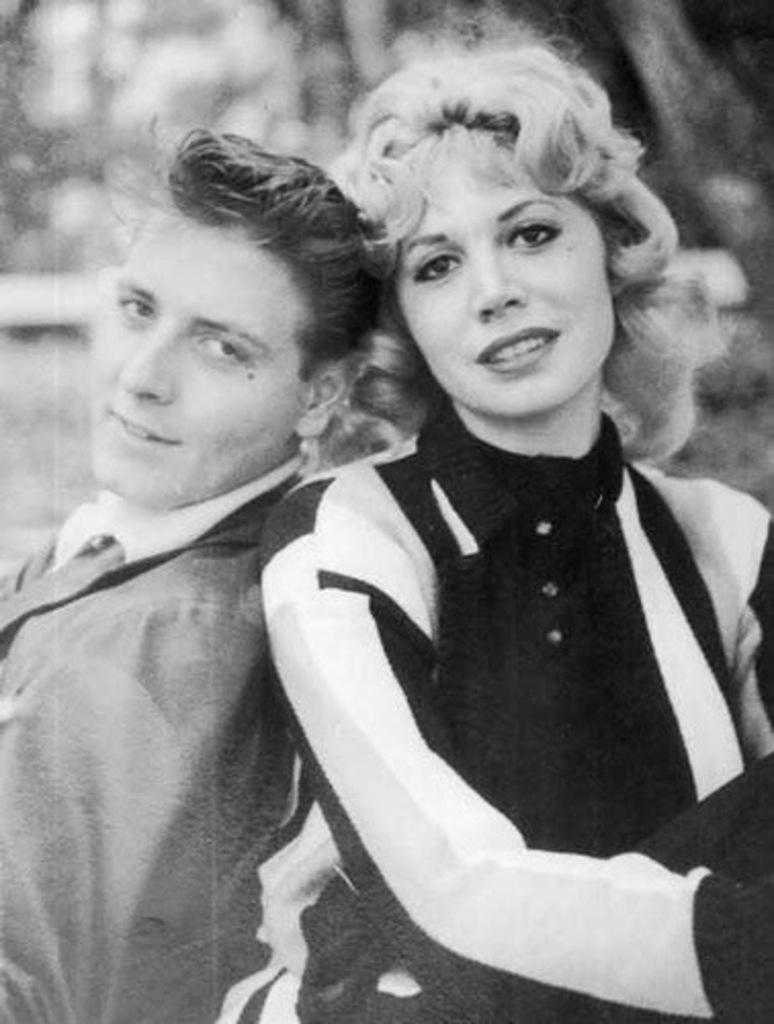How many people are in the image? There are two people in the image. Can you describe the lady in the image? The lady is on the right side of the image. Can you describe the man in the image? The man is on the left side of the image. What type of fang can be seen in the man's mouth in the image? There is no fang visible in the man's mouth in the image. What type of patch is the lady wearing on her arm in the image? There is no patch visible on the lady's arm in the image. 